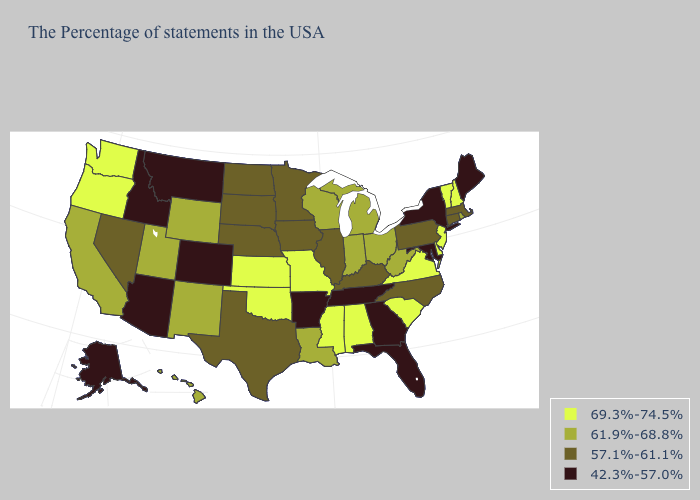What is the value of Maryland?
Be succinct. 42.3%-57.0%. Does the map have missing data?
Concise answer only. No. What is the value of New Hampshire?
Keep it brief. 69.3%-74.5%. Name the states that have a value in the range 61.9%-68.8%?
Short answer required. Rhode Island, West Virginia, Ohio, Michigan, Indiana, Wisconsin, Louisiana, Wyoming, New Mexico, Utah, California, Hawaii. Among the states that border Mississippi , which have the lowest value?
Answer briefly. Tennessee, Arkansas. Among the states that border Wyoming , which have the highest value?
Be succinct. Utah. What is the value of Hawaii?
Concise answer only. 61.9%-68.8%. What is the highest value in the Northeast ?
Write a very short answer. 69.3%-74.5%. Does Alabama have the highest value in the USA?
Be succinct. Yes. Among the states that border Washington , which have the highest value?
Quick response, please. Oregon. What is the value of Illinois?
Quick response, please. 57.1%-61.1%. What is the value of Illinois?
Answer briefly. 57.1%-61.1%. What is the highest value in the USA?
Concise answer only. 69.3%-74.5%. What is the value of New York?
Write a very short answer. 42.3%-57.0%. Does the first symbol in the legend represent the smallest category?
Concise answer only. No. 